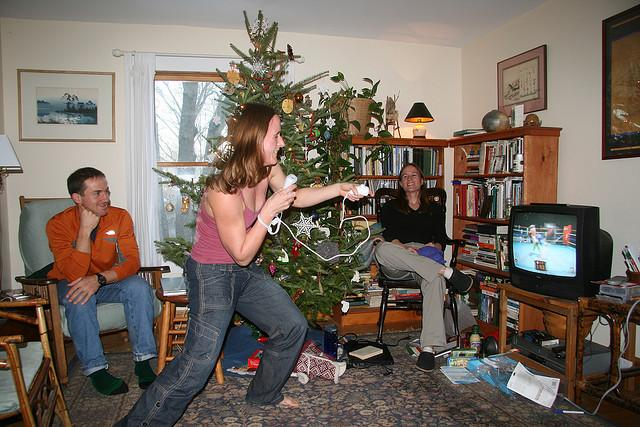What type of television display technology is being used in the living room?

Choices:
A) oled
B) crt
C) plasma
D) lcd crt 